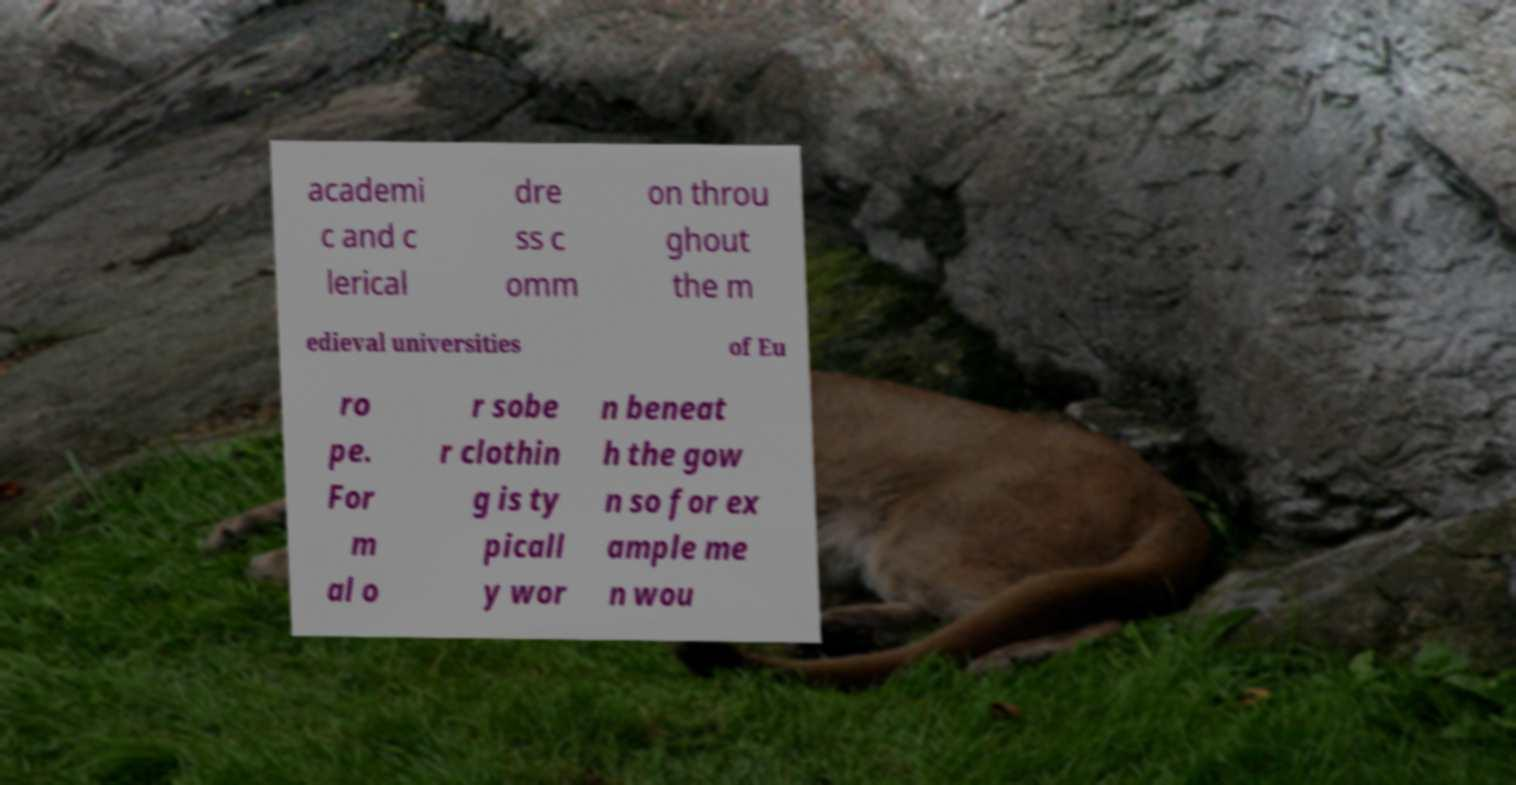Could you extract and type out the text from this image? academi c and c lerical dre ss c omm on throu ghout the m edieval universities of Eu ro pe. For m al o r sobe r clothin g is ty picall y wor n beneat h the gow n so for ex ample me n wou 